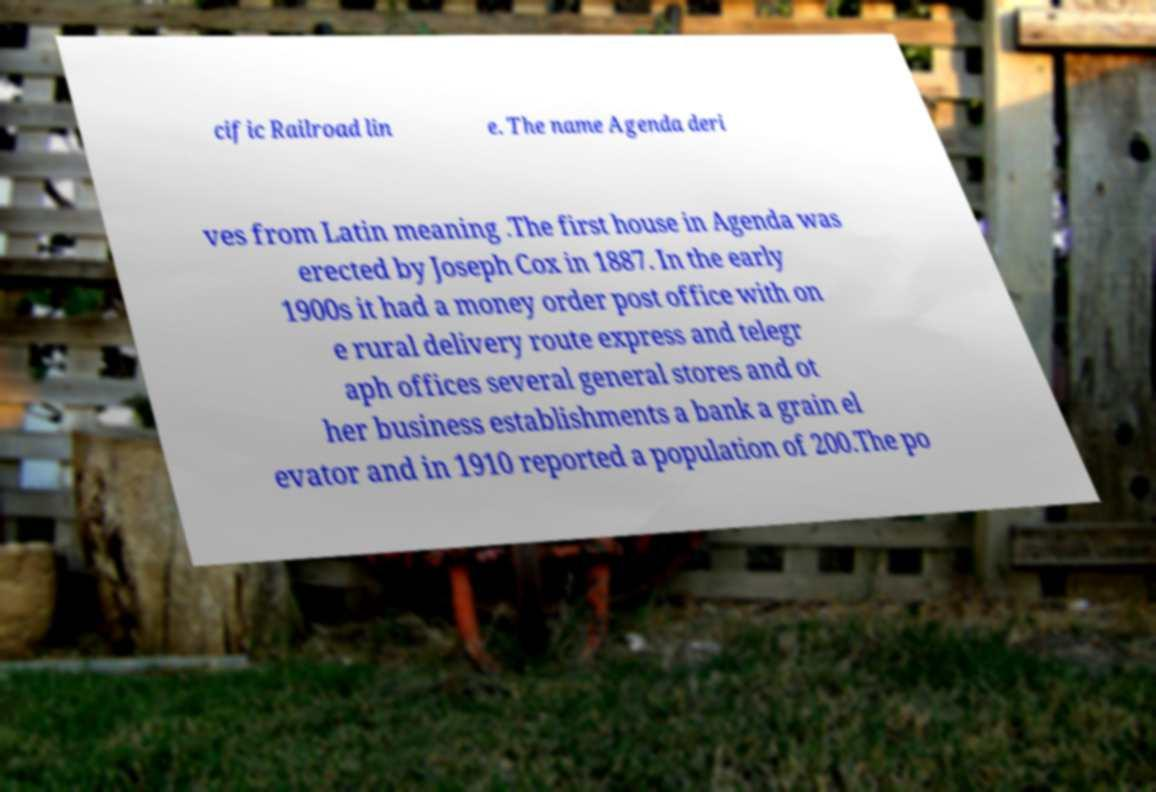Please read and relay the text visible in this image. What does it say? cific Railroad lin e. The name Agenda deri ves from Latin meaning .The first house in Agenda was erected by Joseph Cox in 1887. In the early 1900s it had a money order post office with on e rural delivery route express and telegr aph offices several general stores and ot her business establishments a bank a grain el evator and in 1910 reported a population of 200.The po 